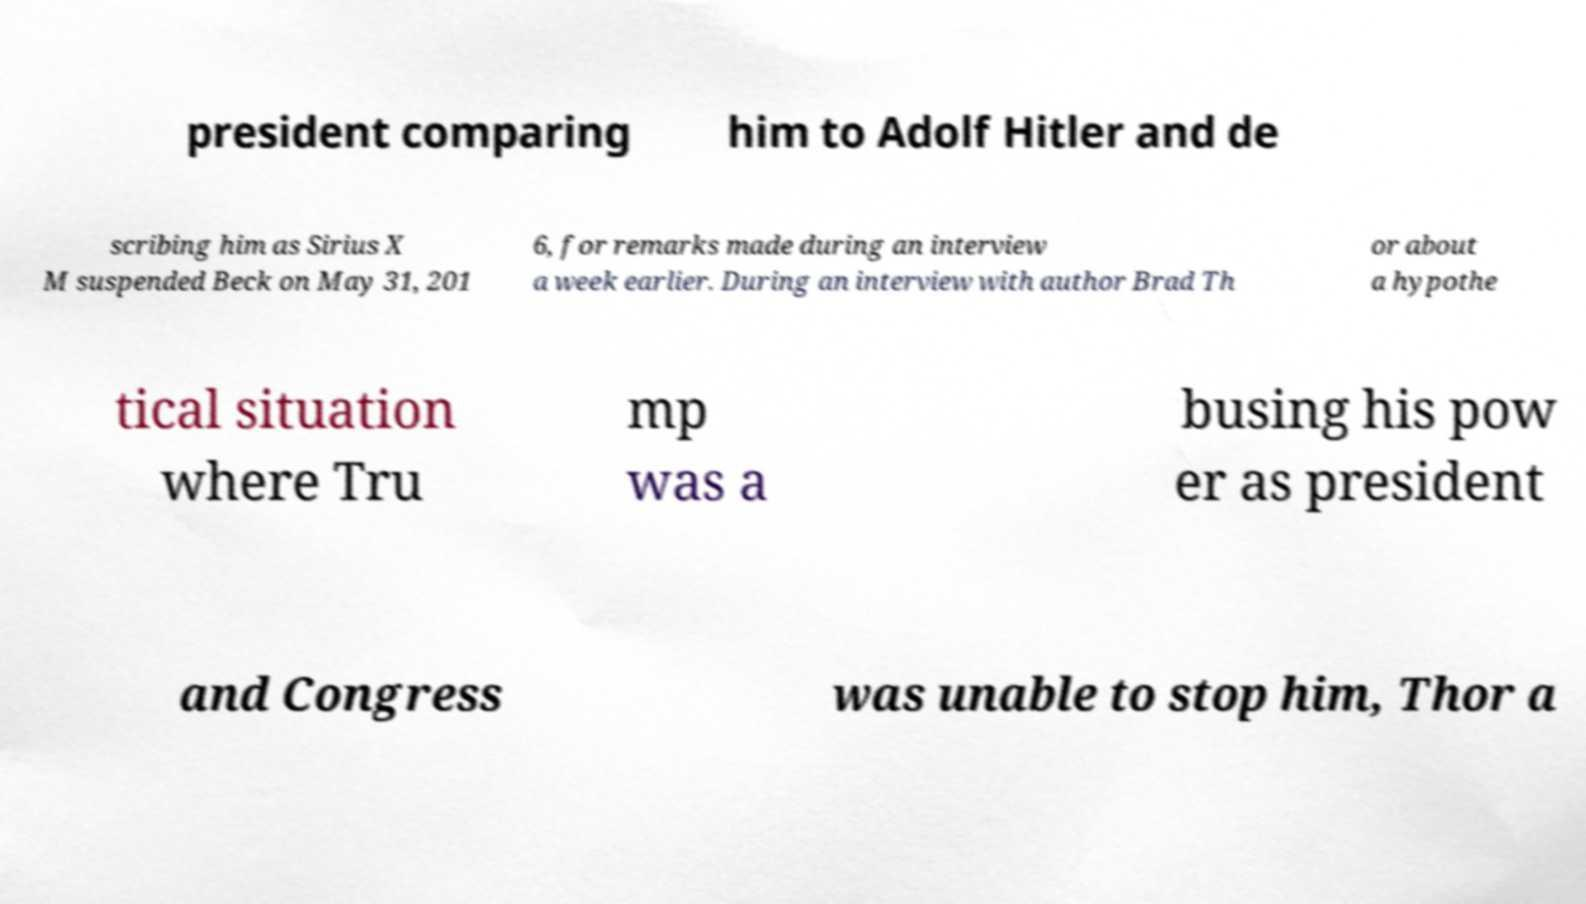Could you extract and type out the text from this image? president comparing him to Adolf Hitler and de scribing him as Sirius X M suspended Beck on May 31, 201 6, for remarks made during an interview a week earlier. During an interview with author Brad Th or about a hypothe tical situation where Tru mp was a busing his pow er as president and Congress was unable to stop him, Thor a 